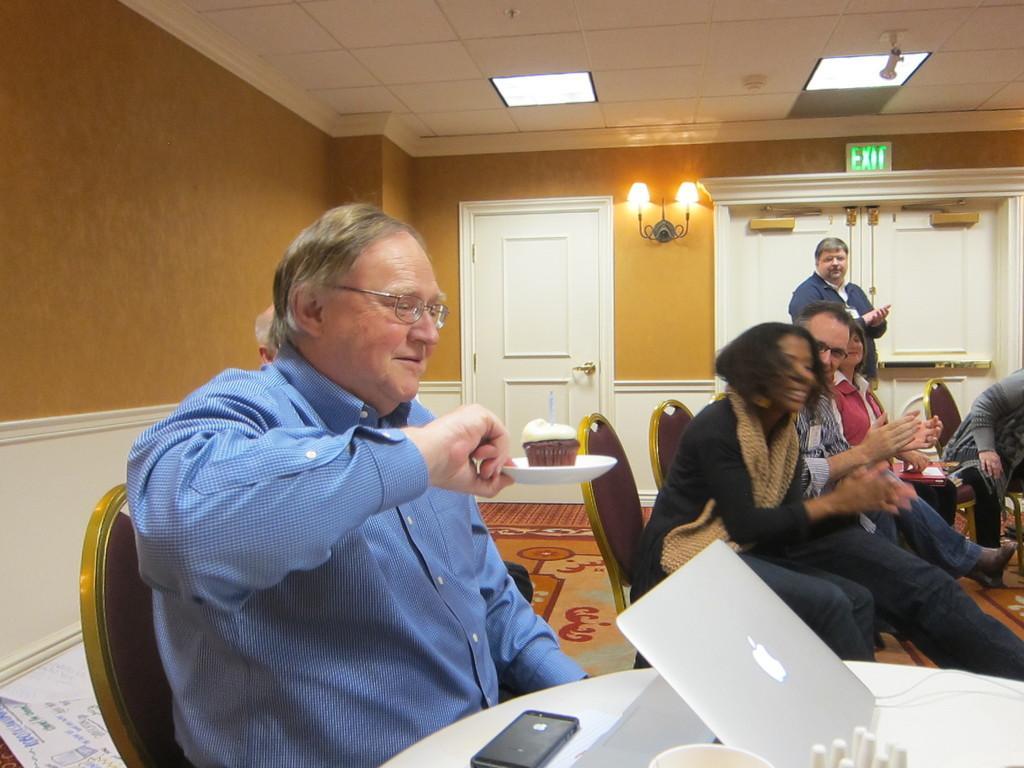Please provide a concise description of this image. On the left side, there is a person in blue color shirt, holding a saucer on which, there is some object and sitting on a chair in front of the table, on which, there is a laptop, mobile and other objects. In the background, there are persons sitting on chairs, there is a person standing, lights attached to the wall, a white door and lights attached to the roof. 